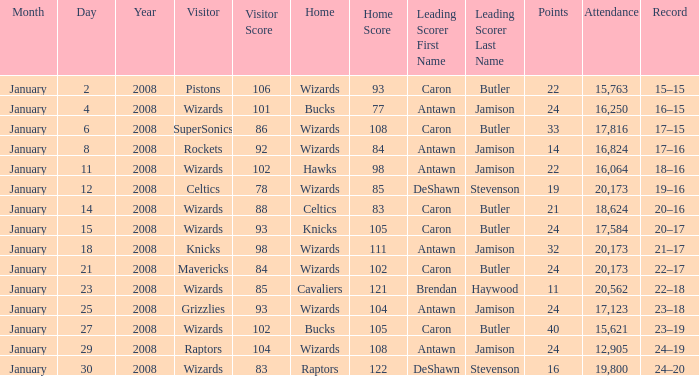What is the record when the leading scorer is Antawn Jamison (14)? 17–16. 